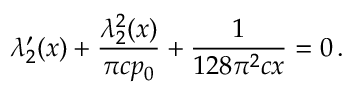<formula> <loc_0><loc_0><loc_500><loc_500>\lambda _ { 2 } ^ { \prime } ( x ) + \frac { \lambda _ { 2 } ^ { 2 } ( x ) } { \pi c p _ { 0 } } + \frac { 1 } { 1 2 8 \pi ^ { 2 } c x } = 0 \, .</formula> 